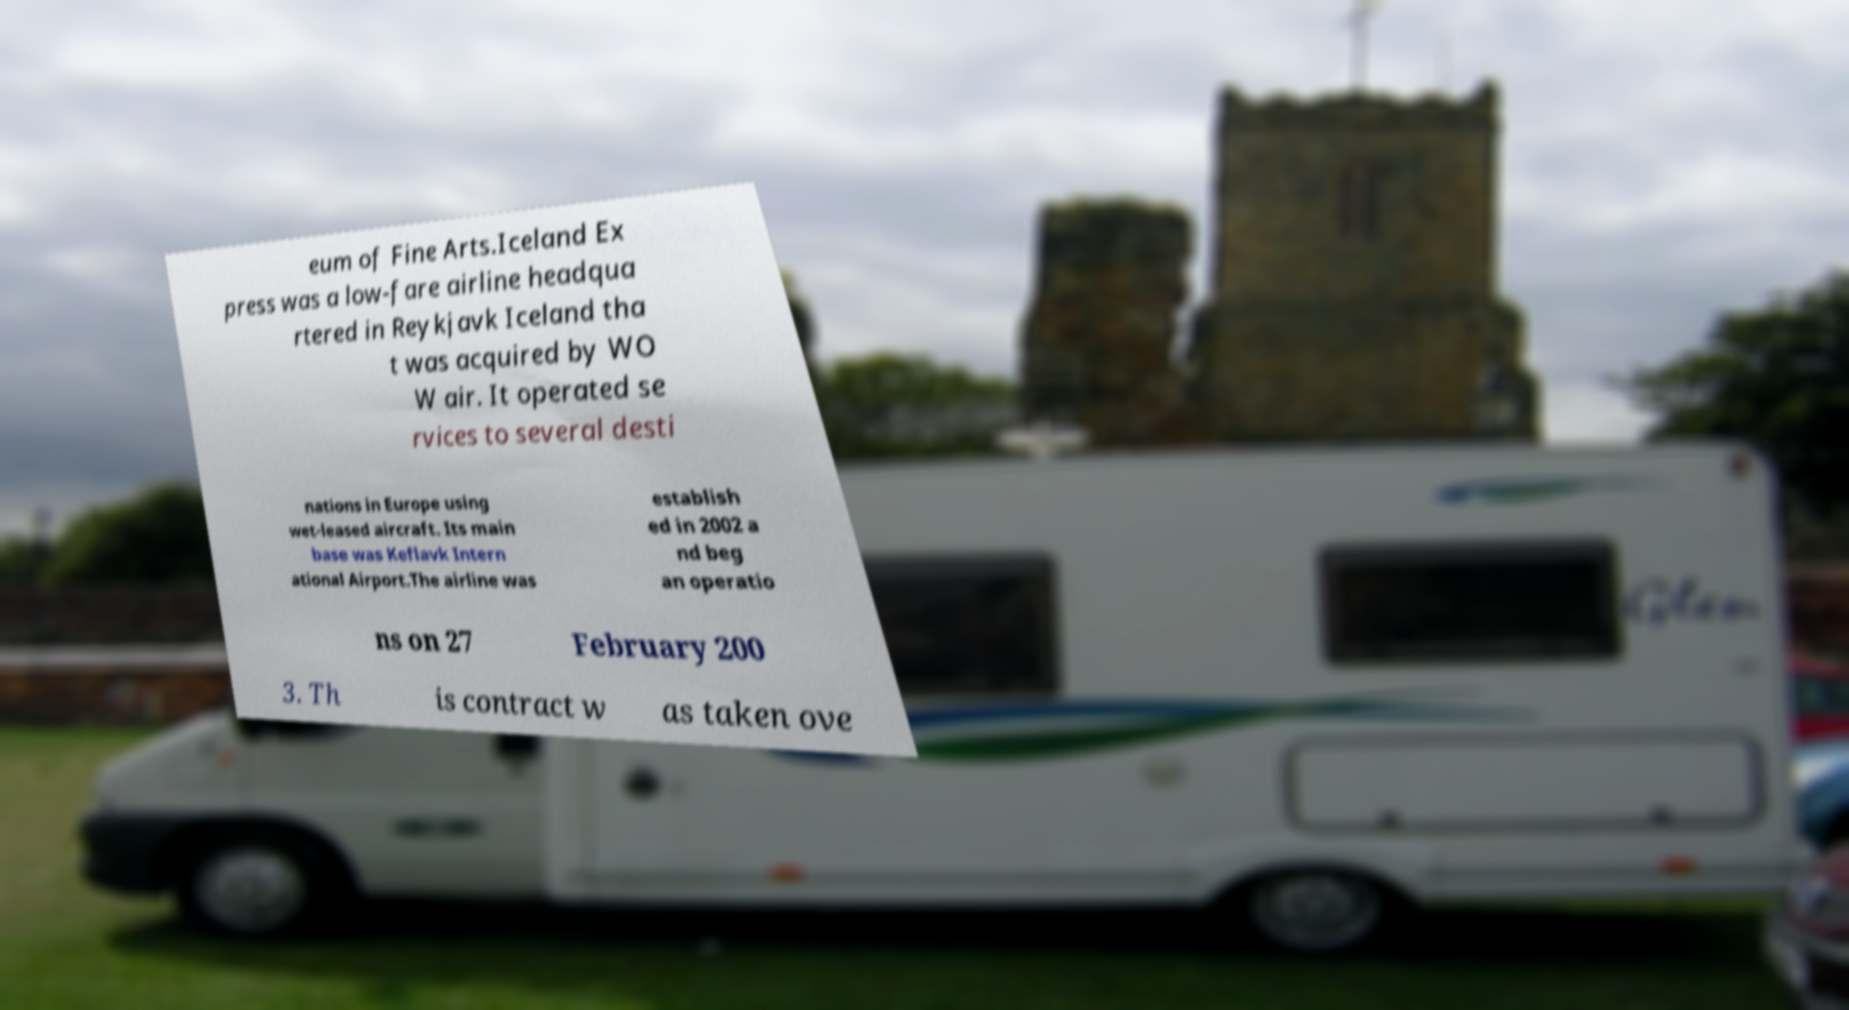Can you read and provide the text displayed in the image?This photo seems to have some interesting text. Can you extract and type it out for me? eum of Fine Arts.Iceland Ex press was a low-fare airline headqua rtered in Reykjavk Iceland tha t was acquired by WO W air. It operated se rvices to several desti nations in Europe using wet-leased aircraft. Its main base was Keflavk Intern ational Airport.The airline was establish ed in 2002 a nd beg an operatio ns on 27 February 200 3. Th is contract w as taken ove 